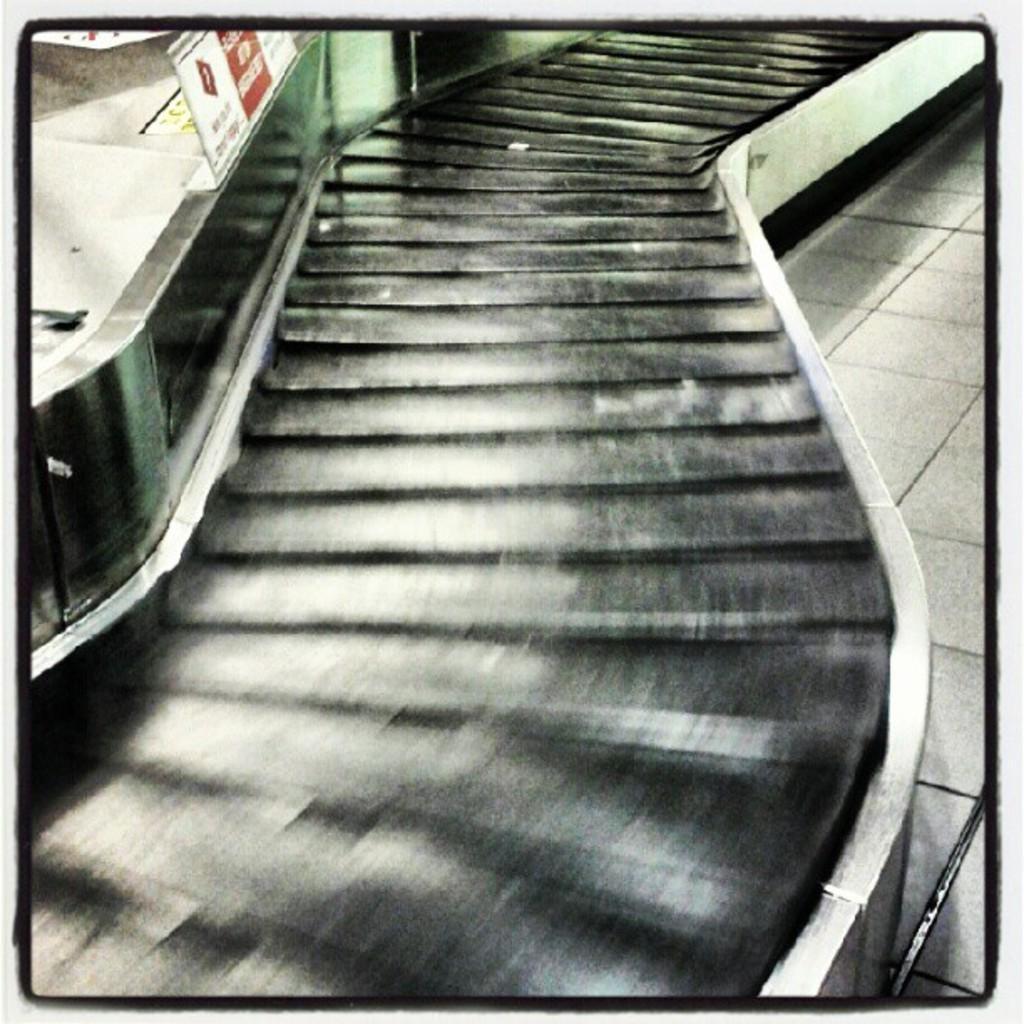Please provide a concise description of this image. In this image it looks like a stairs on the floor. And at the side there is a board and the text written on it. 